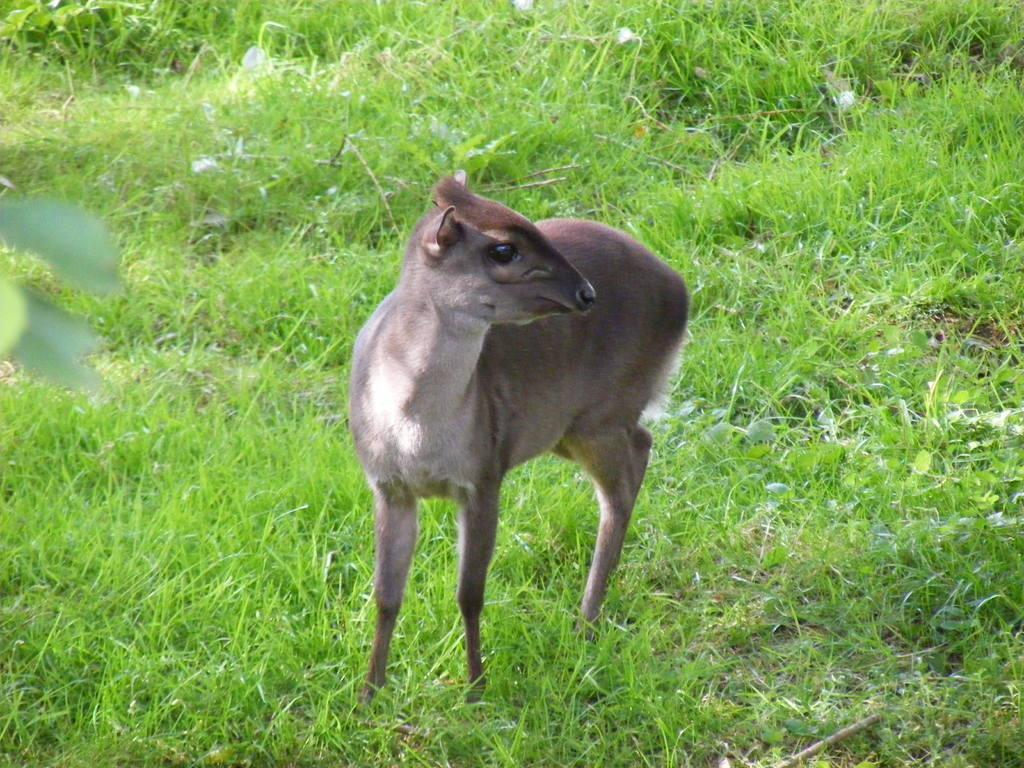What is the main subject in the center of the image? There is an animal in the center of the image. What type of vegetation is visible at the bottom of the image? There is grass at the bottom of the image. What can be seen on the left side of the image? There are leaves on the left side of the image. What type of cake is being served on the right side of the image? There is no cake present in the image; it only features an animal, grass, and leaves. Can you see a fish swimming in the grass in the image? There is no fish present in the image; it only features an animal, grass, and leaves. 